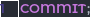Convert code to text. <code><loc_0><loc_0><loc_500><loc_500><_SQL_>
COMMIT;
</code> 